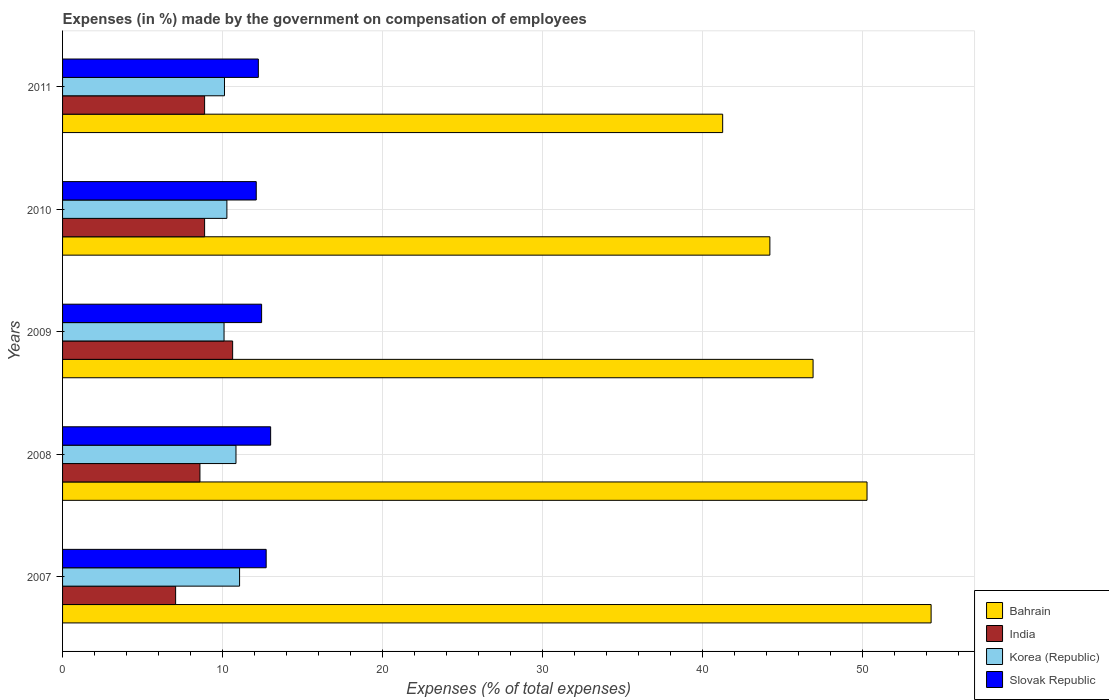How many groups of bars are there?
Provide a short and direct response. 5. Are the number of bars on each tick of the Y-axis equal?
Offer a terse response. Yes. How many bars are there on the 3rd tick from the top?
Your answer should be very brief. 4. How many bars are there on the 3rd tick from the bottom?
Provide a short and direct response. 4. What is the label of the 1st group of bars from the top?
Your answer should be very brief. 2011. In how many cases, is the number of bars for a given year not equal to the number of legend labels?
Your response must be concise. 0. What is the percentage of expenses made by the government on compensation of employees in Korea (Republic) in 2010?
Provide a short and direct response. 10.27. Across all years, what is the maximum percentage of expenses made by the government on compensation of employees in Bahrain?
Your answer should be compact. 54.31. Across all years, what is the minimum percentage of expenses made by the government on compensation of employees in India?
Provide a short and direct response. 7.07. What is the total percentage of expenses made by the government on compensation of employees in India in the graph?
Ensure brevity in your answer.  44.05. What is the difference between the percentage of expenses made by the government on compensation of employees in Korea (Republic) in 2007 and that in 2010?
Give a very brief answer. 0.79. What is the difference between the percentage of expenses made by the government on compensation of employees in India in 2008 and the percentage of expenses made by the government on compensation of employees in Bahrain in 2007?
Your answer should be very brief. -45.72. What is the average percentage of expenses made by the government on compensation of employees in Korea (Republic) per year?
Provide a short and direct response. 10.48. In the year 2008, what is the difference between the percentage of expenses made by the government on compensation of employees in Slovak Republic and percentage of expenses made by the government on compensation of employees in Korea (Republic)?
Offer a very short reply. 2.17. What is the ratio of the percentage of expenses made by the government on compensation of employees in India in 2007 to that in 2009?
Offer a very short reply. 0.66. What is the difference between the highest and the second highest percentage of expenses made by the government on compensation of employees in India?
Provide a short and direct response. 1.75. What is the difference between the highest and the lowest percentage of expenses made by the government on compensation of employees in Bahrain?
Ensure brevity in your answer.  13.03. Is the sum of the percentage of expenses made by the government on compensation of employees in Bahrain in 2008 and 2011 greater than the maximum percentage of expenses made by the government on compensation of employees in Slovak Republic across all years?
Your response must be concise. Yes. What does the 1st bar from the bottom in 2011 represents?
Give a very brief answer. Bahrain. Is it the case that in every year, the sum of the percentage of expenses made by the government on compensation of employees in Bahrain and percentage of expenses made by the government on compensation of employees in Korea (Republic) is greater than the percentage of expenses made by the government on compensation of employees in Slovak Republic?
Provide a succinct answer. Yes. Are all the bars in the graph horizontal?
Ensure brevity in your answer.  Yes. Are the values on the major ticks of X-axis written in scientific E-notation?
Provide a short and direct response. No. Does the graph contain any zero values?
Your answer should be very brief. No. How many legend labels are there?
Give a very brief answer. 4. How are the legend labels stacked?
Provide a short and direct response. Vertical. What is the title of the graph?
Provide a succinct answer. Expenses (in %) made by the government on compensation of employees. What is the label or title of the X-axis?
Your answer should be very brief. Expenses (% of total expenses). What is the Expenses (% of total expenses) of Bahrain in 2007?
Your answer should be very brief. 54.31. What is the Expenses (% of total expenses) in India in 2007?
Your answer should be compact. 7.07. What is the Expenses (% of total expenses) in Korea (Republic) in 2007?
Your answer should be very brief. 11.07. What is the Expenses (% of total expenses) in Slovak Republic in 2007?
Provide a short and direct response. 12.73. What is the Expenses (% of total expenses) in Bahrain in 2008?
Keep it short and to the point. 50.3. What is the Expenses (% of total expenses) of India in 2008?
Keep it short and to the point. 8.59. What is the Expenses (% of total expenses) in Korea (Republic) in 2008?
Your response must be concise. 10.84. What is the Expenses (% of total expenses) of Slovak Republic in 2008?
Keep it short and to the point. 13.01. What is the Expenses (% of total expenses) of Bahrain in 2009?
Ensure brevity in your answer.  46.93. What is the Expenses (% of total expenses) in India in 2009?
Provide a succinct answer. 10.63. What is the Expenses (% of total expenses) in Korea (Republic) in 2009?
Provide a short and direct response. 10.1. What is the Expenses (% of total expenses) of Slovak Republic in 2009?
Provide a short and direct response. 12.45. What is the Expenses (% of total expenses) of Bahrain in 2010?
Your response must be concise. 44.22. What is the Expenses (% of total expenses) in India in 2010?
Offer a very short reply. 8.88. What is the Expenses (% of total expenses) in Korea (Republic) in 2010?
Your response must be concise. 10.27. What is the Expenses (% of total expenses) of Slovak Republic in 2010?
Your answer should be compact. 12.11. What is the Expenses (% of total expenses) of Bahrain in 2011?
Offer a terse response. 41.27. What is the Expenses (% of total expenses) in India in 2011?
Give a very brief answer. 8.88. What is the Expenses (% of total expenses) in Korea (Republic) in 2011?
Your answer should be compact. 10.12. What is the Expenses (% of total expenses) of Slovak Republic in 2011?
Ensure brevity in your answer.  12.24. Across all years, what is the maximum Expenses (% of total expenses) in Bahrain?
Your answer should be compact. 54.31. Across all years, what is the maximum Expenses (% of total expenses) of India?
Provide a short and direct response. 10.63. Across all years, what is the maximum Expenses (% of total expenses) of Korea (Republic)?
Your response must be concise. 11.07. Across all years, what is the maximum Expenses (% of total expenses) in Slovak Republic?
Your response must be concise. 13.01. Across all years, what is the minimum Expenses (% of total expenses) of Bahrain?
Your answer should be very brief. 41.27. Across all years, what is the minimum Expenses (% of total expenses) of India?
Provide a short and direct response. 7.07. Across all years, what is the minimum Expenses (% of total expenses) in Korea (Republic)?
Provide a short and direct response. 10.1. Across all years, what is the minimum Expenses (% of total expenses) of Slovak Republic?
Ensure brevity in your answer.  12.11. What is the total Expenses (% of total expenses) in Bahrain in the graph?
Your answer should be compact. 237.03. What is the total Expenses (% of total expenses) in India in the graph?
Your answer should be very brief. 44.05. What is the total Expenses (% of total expenses) in Korea (Republic) in the graph?
Your response must be concise. 52.41. What is the total Expenses (% of total expenses) in Slovak Republic in the graph?
Provide a short and direct response. 62.54. What is the difference between the Expenses (% of total expenses) of Bahrain in 2007 and that in 2008?
Give a very brief answer. 4.01. What is the difference between the Expenses (% of total expenses) in India in 2007 and that in 2008?
Ensure brevity in your answer.  -1.52. What is the difference between the Expenses (% of total expenses) of Korea (Republic) in 2007 and that in 2008?
Your answer should be compact. 0.22. What is the difference between the Expenses (% of total expenses) in Slovak Republic in 2007 and that in 2008?
Make the answer very short. -0.28. What is the difference between the Expenses (% of total expenses) of Bahrain in 2007 and that in 2009?
Your answer should be very brief. 7.38. What is the difference between the Expenses (% of total expenses) of India in 2007 and that in 2009?
Offer a very short reply. -3.56. What is the difference between the Expenses (% of total expenses) of Korea (Republic) in 2007 and that in 2009?
Your response must be concise. 0.97. What is the difference between the Expenses (% of total expenses) in Slovak Republic in 2007 and that in 2009?
Offer a very short reply. 0.29. What is the difference between the Expenses (% of total expenses) of Bahrain in 2007 and that in 2010?
Provide a short and direct response. 10.08. What is the difference between the Expenses (% of total expenses) of India in 2007 and that in 2010?
Offer a very short reply. -1.81. What is the difference between the Expenses (% of total expenses) in Korea (Republic) in 2007 and that in 2010?
Offer a very short reply. 0.79. What is the difference between the Expenses (% of total expenses) of Slovak Republic in 2007 and that in 2010?
Give a very brief answer. 0.62. What is the difference between the Expenses (% of total expenses) of Bahrain in 2007 and that in 2011?
Offer a very short reply. 13.03. What is the difference between the Expenses (% of total expenses) in India in 2007 and that in 2011?
Make the answer very short. -1.81. What is the difference between the Expenses (% of total expenses) in Korea (Republic) in 2007 and that in 2011?
Keep it short and to the point. 0.94. What is the difference between the Expenses (% of total expenses) of Slovak Republic in 2007 and that in 2011?
Your answer should be compact. 0.49. What is the difference between the Expenses (% of total expenses) of Bahrain in 2008 and that in 2009?
Ensure brevity in your answer.  3.37. What is the difference between the Expenses (% of total expenses) in India in 2008 and that in 2009?
Make the answer very short. -2.04. What is the difference between the Expenses (% of total expenses) in Korea (Republic) in 2008 and that in 2009?
Make the answer very short. 0.75. What is the difference between the Expenses (% of total expenses) of Slovak Republic in 2008 and that in 2009?
Make the answer very short. 0.56. What is the difference between the Expenses (% of total expenses) in Bahrain in 2008 and that in 2010?
Your response must be concise. 6.08. What is the difference between the Expenses (% of total expenses) of India in 2008 and that in 2010?
Provide a short and direct response. -0.29. What is the difference between the Expenses (% of total expenses) in Korea (Republic) in 2008 and that in 2010?
Offer a very short reply. 0.57. What is the difference between the Expenses (% of total expenses) of Slovak Republic in 2008 and that in 2010?
Offer a terse response. 0.9. What is the difference between the Expenses (% of total expenses) of Bahrain in 2008 and that in 2011?
Provide a short and direct response. 9.03. What is the difference between the Expenses (% of total expenses) in India in 2008 and that in 2011?
Keep it short and to the point. -0.29. What is the difference between the Expenses (% of total expenses) in Korea (Republic) in 2008 and that in 2011?
Keep it short and to the point. 0.72. What is the difference between the Expenses (% of total expenses) in Slovak Republic in 2008 and that in 2011?
Give a very brief answer. 0.77. What is the difference between the Expenses (% of total expenses) in Bahrain in 2009 and that in 2010?
Give a very brief answer. 2.7. What is the difference between the Expenses (% of total expenses) in India in 2009 and that in 2010?
Ensure brevity in your answer.  1.75. What is the difference between the Expenses (% of total expenses) in Korea (Republic) in 2009 and that in 2010?
Offer a very short reply. -0.18. What is the difference between the Expenses (% of total expenses) in Slovak Republic in 2009 and that in 2010?
Offer a very short reply. 0.34. What is the difference between the Expenses (% of total expenses) in Bahrain in 2009 and that in 2011?
Give a very brief answer. 5.65. What is the difference between the Expenses (% of total expenses) in India in 2009 and that in 2011?
Your response must be concise. 1.75. What is the difference between the Expenses (% of total expenses) of Korea (Republic) in 2009 and that in 2011?
Ensure brevity in your answer.  -0.03. What is the difference between the Expenses (% of total expenses) in Slovak Republic in 2009 and that in 2011?
Your answer should be compact. 0.2. What is the difference between the Expenses (% of total expenses) in Bahrain in 2010 and that in 2011?
Offer a terse response. 2.95. What is the difference between the Expenses (% of total expenses) of Korea (Republic) in 2010 and that in 2011?
Provide a short and direct response. 0.15. What is the difference between the Expenses (% of total expenses) of Slovak Republic in 2010 and that in 2011?
Your response must be concise. -0.13. What is the difference between the Expenses (% of total expenses) in Bahrain in 2007 and the Expenses (% of total expenses) in India in 2008?
Keep it short and to the point. 45.72. What is the difference between the Expenses (% of total expenses) of Bahrain in 2007 and the Expenses (% of total expenses) of Korea (Republic) in 2008?
Offer a terse response. 43.46. What is the difference between the Expenses (% of total expenses) in Bahrain in 2007 and the Expenses (% of total expenses) in Slovak Republic in 2008?
Provide a short and direct response. 41.3. What is the difference between the Expenses (% of total expenses) of India in 2007 and the Expenses (% of total expenses) of Korea (Republic) in 2008?
Your response must be concise. -3.77. What is the difference between the Expenses (% of total expenses) in India in 2007 and the Expenses (% of total expenses) in Slovak Republic in 2008?
Provide a succinct answer. -5.94. What is the difference between the Expenses (% of total expenses) of Korea (Republic) in 2007 and the Expenses (% of total expenses) of Slovak Republic in 2008?
Offer a very short reply. -1.94. What is the difference between the Expenses (% of total expenses) in Bahrain in 2007 and the Expenses (% of total expenses) in India in 2009?
Your answer should be compact. 43.67. What is the difference between the Expenses (% of total expenses) of Bahrain in 2007 and the Expenses (% of total expenses) of Korea (Republic) in 2009?
Offer a very short reply. 44.21. What is the difference between the Expenses (% of total expenses) in Bahrain in 2007 and the Expenses (% of total expenses) in Slovak Republic in 2009?
Give a very brief answer. 41.86. What is the difference between the Expenses (% of total expenses) of India in 2007 and the Expenses (% of total expenses) of Korea (Republic) in 2009?
Give a very brief answer. -3.03. What is the difference between the Expenses (% of total expenses) in India in 2007 and the Expenses (% of total expenses) in Slovak Republic in 2009?
Give a very brief answer. -5.38. What is the difference between the Expenses (% of total expenses) in Korea (Republic) in 2007 and the Expenses (% of total expenses) in Slovak Republic in 2009?
Provide a succinct answer. -1.38. What is the difference between the Expenses (% of total expenses) of Bahrain in 2007 and the Expenses (% of total expenses) of India in 2010?
Keep it short and to the point. 45.42. What is the difference between the Expenses (% of total expenses) in Bahrain in 2007 and the Expenses (% of total expenses) in Korea (Republic) in 2010?
Give a very brief answer. 44.03. What is the difference between the Expenses (% of total expenses) of Bahrain in 2007 and the Expenses (% of total expenses) of Slovak Republic in 2010?
Ensure brevity in your answer.  42.2. What is the difference between the Expenses (% of total expenses) of India in 2007 and the Expenses (% of total expenses) of Korea (Republic) in 2010?
Keep it short and to the point. -3.2. What is the difference between the Expenses (% of total expenses) of India in 2007 and the Expenses (% of total expenses) of Slovak Republic in 2010?
Make the answer very short. -5.04. What is the difference between the Expenses (% of total expenses) in Korea (Republic) in 2007 and the Expenses (% of total expenses) in Slovak Republic in 2010?
Your answer should be very brief. -1.04. What is the difference between the Expenses (% of total expenses) in Bahrain in 2007 and the Expenses (% of total expenses) in India in 2011?
Keep it short and to the point. 45.42. What is the difference between the Expenses (% of total expenses) of Bahrain in 2007 and the Expenses (% of total expenses) of Korea (Republic) in 2011?
Give a very brief answer. 44.18. What is the difference between the Expenses (% of total expenses) in Bahrain in 2007 and the Expenses (% of total expenses) in Slovak Republic in 2011?
Give a very brief answer. 42.06. What is the difference between the Expenses (% of total expenses) in India in 2007 and the Expenses (% of total expenses) in Korea (Republic) in 2011?
Provide a short and direct response. -3.06. What is the difference between the Expenses (% of total expenses) of India in 2007 and the Expenses (% of total expenses) of Slovak Republic in 2011?
Ensure brevity in your answer.  -5.17. What is the difference between the Expenses (% of total expenses) in Korea (Republic) in 2007 and the Expenses (% of total expenses) in Slovak Republic in 2011?
Offer a terse response. -1.17. What is the difference between the Expenses (% of total expenses) of Bahrain in 2008 and the Expenses (% of total expenses) of India in 2009?
Your response must be concise. 39.67. What is the difference between the Expenses (% of total expenses) of Bahrain in 2008 and the Expenses (% of total expenses) of Korea (Republic) in 2009?
Keep it short and to the point. 40.2. What is the difference between the Expenses (% of total expenses) in Bahrain in 2008 and the Expenses (% of total expenses) in Slovak Republic in 2009?
Give a very brief answer. 37.85. What is the difference between the Expenses (% of total expenses) of India in 2008 and the Expenses (% of total expenses) of Korea (Republic) in 2009?
Your answer should be compact. -1.51. What is the difference between the Expenses (% of total expenses) in India in 2008 and the Expenses (% of total expenses) in Slovak Republic in 2009?
Offer a terse response. -3.86. What is the difference between the Expenses (% of total expenses) in Korea (Republic) in 2008 and the Expenses (% of total expenses) in Slovak Republic in 2009?
Ensure brevity in your answer.  -1.6. What is the difference between the Expenses (% of total expenses) of Bahrain in 2008 and the Expenses (% of total expenses) of India in 2010?
Keep it short and to the point. 41.42. What is the difference between the Expenses (% of total expenses) of Bahrain in 2008 and the Expenses (% of total expenses) of Korea (Republic) in 2010?
Make the answer very short. 40.03. What is the difference between the Expenses (% of total expenses) of Bahrain in 2008 and the Expenses (% of total expenses) of Slovak Republic in 2010?
Ensure brevity in your answer.  38.19. What is the difference between the Expenses (% of total expenses) in India in 2008 and the Expenses (% of total expenses) in Korea (Republic) in 2010?
Provide a short and direct response. -1.69. What is the difference between the Expenses (% of total expenses) of India in 2008 and the Expenses (% of total expenses) of Slovak Republic in 2010?
Give a very brief answer. -3.52. What is the difference between the Expenses (% of total expenses) of Korea (Republic) in 2008 and the Expenses (% of total expenses) of Slovak Republic in 2010?
Your response must be concise. -1.27. What is the difference between the Expenses (% of total expenses) of Bahrain in 2008 and the Expenses (% of total expenses) of India in 2011?
Offer a terse response. 41.42. What is the difference between the Expenses (% of total expenses) of Bahrain in 2008 and the Expenses (% of total expenses) of Korea (Republic) in 2011?
Ensure brevity in your answer.  40.17. What is the difference between the Expenses (% of total expenses) of Bahrain in 2008 and the Expenses (% of total expenses) of Slovak Republic in 2011?
Give a very brief answer. 38.06. What is the difference between the Expenses (% of total expenses) in India in 2008 and the Expenses (% of total expenses) in Korea (Republic) in 2011?
Your response must be concise. -1.54. What is the difference between the Expenses (% of total expenses) in India in 2008 and the Expenses (% of total expenses) in Slovak Republic in 2011?
Make the answer very short. -3.65. What is the difference between the Expenses (% of total expenses) of Korea (Republic) in 2008 and the Expenses (% of total expenses) of Slovak Republic in 2011?
Your answer should be compact. -1.4. What is the difference between the Expenses (% of total expenses) in Bahrain in 2009 and the Expenses (% of total expenses) in India in 2010?
Keep it short and to the point. 38.04. What is the difference between the Expenses (% of total expenses) of Bahrain in 2009 and the Expenses (% of total expenses) of Korea (Republic) in 2010?
Your response must be concise. 36.65. What is the difference between the Expenses (% of total expenses) in Bahrain in 2009 and the Expenses (% of total expenses) in Slovak Republic in 2010?
Provide a succinct answer. 34.82. What is the difference between the Expenses (% of total expenses) of India in 2009 and the Expenses (% of total expenses) of Korea (Republic) in 2010?
Give a very brief answer. 0.36. What is the difference between the Expenses (% of total expenses) in India in 2009 and the Expenses (% of total expenses) in Slovak Republic in 2010?
Keep it short and to the point. -1.48. What is the difference between the Expenses (% of total expenses) in Korea (Republic) in 2009 and the Expenses (% of total expenses) in Slovak Republic in 2010?
Provide a short and direct response. -2.01. What is the difference between the Expenses (% of total expenses) in Bahrain in 2009 and the Expenses (% of total expenses) in India in 2011?
Keep it short and to the point. 38.04. What is the difference between the Expenses (% of total expenses) in Bahrain in 2009 and the Expenses (% of total expenses) in Korea (Republic) in 2011?
Provide a short and direct response. 36.8. What is the difference between the Expenses (% of total expenses) in Bahrain in 2009 and the Expenses (% of total expenses) in Slovak Republic in 2011?
Your response must be concise. 34.68. What is the difference between the Expenses (% of total expenses) in India in 2009 and the Expenses (% of total expenses) in Korea (Republic) in 2011?
Give a very brief answer. 0.51. What is the difference between the Expenses (% of total expenses) of India in 2009 and the Expenses (% of total expenses) of Slovak Republic in 2011?
Provide a succinct answer. -1.61. What is the difference between the Expenses (% of total expenses) in Korea (Republic) in 2009 and the Expenses (% of total expenses) in Slovak Republic in 2011?
Provide a short and direct response. -2.14. What is the difference between the Expenses (% of total expenses) in Bahrain in 2010 and the Expenses (% of total expenses) in India in 2011?
Offer a terse response. 35.34. What is the difference between the Expenses (% of total expenses) in Bahrain in 2010 and the Expenses (% of total expenses) in Korea (Republic) in 2011?
Your answer should be very brief. 34.1. What is the difference between the Expenses (% of total expenses) in Bahrain in 2010 and the Expenses (% of total expenses) in Slovak Republic in 2011?
Make the answer very short. 31.98. What is the difference between the Expenses (% of total expenses) in India in 2010 and the Expenses (% of total expenses) in Korea (Republic) in 2011?
Keep it short and to the point. -1.24. What is the difference between the Expenses (% of total expenses) in India in 2010 and the Expenses (% of total expenses) in Slovak Republic in 2011?
Offer a very short reply. -3.36. What is the difference between the Expenses (% of total expenses) in Korea (Republic) in 2010 and the Expenses (% of total expenses) in Slovak Republic in 2011?
Your response must be concise. -1.97. What is the average Expenses (% of total expenses) in Bahrain per year?
Give a very brief answer. 47.41. What is the average Expenses (% of total expenses) of India per year?
Ensure brevity in your answer.  8.81. What is the average Expenses (% of total expenses) of Korea (Republic) per year?
Your answer should be very brief. 10.48. What is the average Expenses (% of total expenses) in Slovak Republic per year?
Keep it short and to the point. 12.51. In the year 2007, what is the difference between the Expenses (% of total expenses) of Bahrain and Expenses (% of total expenses) of India?
Ensure brevity in your answer.  47.24. In the year 2007, what is the difference between the Expenses (% of total expenses) in Bahrain and Expenses (% of total expenses) in Korea (Republic)?
Make the answer very short. 43.24. In the year 2007, what is the difference between the Expenses (% of total expenses) in Bahrain and Expenses (% of total expenses) in Slovak Republic?
Offer a terse response. 41.58. In the year 2007, what is the difference between the Expenses (% of total expenses) in India and Expenses (% of total expenses) in Korea (Republic)?
Give a very brief answer. -4. In the year 2007, what is the difference between the Expenses (% of total expenses) in India and Expenses (% of total expenses) in Slovak Republic?
Your answer should be very brief. -5.66. In the year 2007, what is the difference between the Expenses (% of total expenses) in Korea (Republic) and Expenses (% of total expenses) in Slovak Republic?
Offer a terse response. -1.66. In the year 2008, what is the difference between the Expenses (% of total expenses) of Bahrain and Expenses (% of total expenses) of India?
Provide a succinct answer. 41.71. In the year 2008, what is the difference between the Expenses (% of total expenses) of Bahrain and Expenses (% of total expenses) of Korea (Republic)?
Your response must be concise. 39.46. In the year 2008, what is the difference between the Expenses (% of total expenses) of Bahrain and Expenses (% of total expenses) of Slovak Republic?
Your answer should be very brief. 37.29. In the year 2008, what is the difference between the Expenses (% of total expenses) of India and Expenses (% of total expenses) of Korea (Republic)?
Keep it short and to the point. -2.25. In the year 2008, what is the difference between the Expenses (% of total expenses) of India and Expenses (% of total expenses) of Slovak Republic?
Provide a short and direct response. -4.42. In the year 2008, what is the difference between the Expenses (% of total expenses) in Korea (Republic) and Expenses (% of total expenses) in Slovak Republic?
Provide a short and direct response. -2.17. In the year 2009, what is the difference between the Expenses (% of total expenses) in Bahrain and Expenses (% of total expenses) in India?
Ensure brevity in your answer.  36.29. In the year 2009, what is the difference between the Expenses (% of total expenses) in Bahrain and Expenses (% of total expenses) in Korea (Republic)?
Give a very brief answer. 36.83. In the year 2009, what is the difference between the Expenses (% of total expenses) of Bahrain and Expenses (% of total expenses) of Slovak Republic?
Your answer should be compact. 34.48. In the year 2009, what is the difference between the Expenses (% of total expenses) of India and Expenses (% of total expenses) of Korea (Republic)?
Provide a succinct answer. 0.54. In the year 2009, what is the difference between the Expenses (% of total expenses) of India and Expenses (% of total expenses) of Slovak Republic?
Keep it short and to the point. -1.81. In the year 2009, what is the difference between the Expenses (% of total expenses) of Korea (Republic) and Expenses (% of total expenses) of Slovak Republic?
Offer a very short reply. -2.35. In the year 2010, what is the difference between the Expenses (% of total expenses) of Bahrain and Expenses (% of total expenses) of India?
Your response must be concise. 35.34. In the year 2010, what is the difference between the Expenses (% of total expenses) of Bahrain and Expenses (% of total expenses) of Korea (Republic)?
Keep it short and to the point. 33.95. In the year 2010, what is the difference between the Expenses (% of total expenses) in Bahrain and Expenses (% of total expenses) in Slovak Republic?
Your answer should be very brief. 32.11. In the year 2010, what is the difference between the Expenses (% of total expenses) in India and Expenses (% of total expenses) in Korea (Republic)?
Offer a terse response. -1.39. In the year 2010, what is the difference between the Expenses (% of total expenses) in India and Expenses (% of total expenses) in Slovak Republic?
Provide a short and direct response. -3.23. In the year 2010, what is the difference between the Expenses (% of total expenses) of Korea (Republic) and Expenses (% of total expenses) of Slovak Republic?
Your answer should be compact. -1.84. In the year 2011, what is the difference between the Expenses (% of total expenses) in Bahrain and Expenses (% of total expenses) in India?
Make the answer very short. 32.39. In the year 2011, what is the difference between the Expenses (% of total expenses) of Bahrain and Expenses (% of total expenses) of Korea (Republic)?
Your answer should be compact. 31.15. In the year 2011, what is the difference between the Expenses (% of total expenses) in Bahrain and Expenses (% of total expenses) in Slovak Republic?
Make the answer very short. 29.03. In the year 2011, what is the difference between the Expenses (% of total expenses) in India and Expenses (% of total expenses) in Korea (Republic)?
Ensure brevity in your answer.  -1.24. In the year 2011, what is the difference between the Expenses (% of total expenses) of India and Expenses (% of total expenses) of Slovak Republic?
Your response must be concise. -3.36. In the year 2011, what is the difference between the Expenses (% of total expenses) in Korea (Republic) and Expenses (% of total expenses) in Slovak Republic?
Make the answer very short. -2.12. What is the ratio of the Expenses (% of total expenses) of Bahrain in 2007 to that in 2008?
Ensure brevity in your answer.  1.08. What is the ratio of the Expenses (% of total expenses) of India in 2007 to that in 2008?
Your answer should be very brief. 0.82. What is the ratio of the Expenses (% of total expenses) of Korea (Republic) in 2007 to that in 2008?
Keep it short and to the point. 1.02. What is the ratio of the Expenses (% of total expenses) of Slovak Republic in 2007 to that in 2008?
Provide a succinct answer. 0.98. What is the ratio of the Expenses (% of total expenses) of Bahrain in 2007 to that in 2009?
Provide a short and direct response. 1.16. What is the ratio of the Expenses (% of total expenses) in India in 2007 to that in 2009?
Provide a short and direct response. 0.66. What is the ratio of the Expenses (% of total expenses) in Korea (Republic) in 2007 to that in 2009?
Ensure brevity in your answer.  1.1. What is the ratio of the Expenses (% of total expenses) in Slovak Republic in 2007 to that in 2009?
Keep it short and to the point. 1.02. What is the ratio of the Expenses (% of total expenses) of Bahrain in 2007 to that in 2010?
Your response must be concise. 1.23. What is the ratio of the Expenses (% of total expenses) in India in 2007 to that in 2010?
Provide a short and direct response. 0.8. What is the ratio of the Expenses (% of total expenses) of Korea (Republic) in 2007 to that in 2010?
Keep it short and to the point. 1.08. What is the ratio of the Expenses (% of total expenses) of Slovak Republic in 2007 to that in 2010?
Ensure brevity in your answer.  1.05. What is the ratio of the Expenses (% of total expenses) in Bahrain in 2007 to that in 2011?
Your answer should be very brief. 1.32. What is the ratio of the Expenses (% of total expenses) of India in 2007 to that in 2011?
Offer a very short reply. 0.8. What is the ratio of the Expenses (% of total expenses) of Korea (Republic) in 2007 to that in 2011?
Your answer should be compact. 1.09. What is the ratio of the Expenses (% of total expenses) in Slovak Republic in 2007 to that in 2011?
Offer a terse response. 1.04. What is the ratio of the Expenses (% of total expenses) in Bahrain in 2008 to that in 2009?
Your response must be concise. 1.07. What is the ratio of the Expenses (% of total expenses) of India in 2008 to that in 2009?
Ensure brevity in your answer.  0.81. What is the ratio of the Expenses (% of total expenses) of Korea (Republic) in 2008 to that in 2009?
Give a very brief answer. 1.07. What is the ratio of the Expenses (% of total expenses) in Slovak Republic in 2008 to that in 2009?
Your answer should be compact. 1.05. What is the ratio of the Expenses (% of total expenses) of Bahrain in 2008 to that in 2010?
Provide a succinct answer. 1.14. What is the ratio of the Expenses (% of total expenses) in India in 2008 to that in 2010?
Give a very brief answer. 0.97. What is the ratio of the Expenses (% of total expenses) of Korea (Republic) in 2008 to that in 2010?
Give a very brief answer. 1.06. What is the ratio of the Expenses (% of total expenses) of Slovak Republic in 2008 to that in 2010?
Your answer should be very brief. 1.07. What is the ratio of the Expenses (% of total expenses) in Bahrain in 2008 to that in 2011?
Ensure brevity in your answer.  1.22. What is the ratio of the Expenses (% of total expenses) of India in 2008 to that in 2011?
Provide a succinct answer. 0.97. What is the ratio of the Expenses (% of total expenses) of Korea (Republic) in 2008 to that in 2011?
Offer a terse response. 1.07. What is the ratio of the Expenses (% of total expenses) in Slovak Republic in 2008 to that in 2011?
Ensure brevity in your answer.  1.06. What is the ratio of the Expenses (% of total expenses) of Bahrain in 2009 to that in 2010?
Keep it short and to the point. 1.06. What is the ratio of the Expenses (% of total expenses) of India in 2009 to that in 2010?
Keep it short and to the point. 1.2. What is the ratio of the Expenses (% of total expenses) of Korea (Republic) in 2009 to that in 2010?
Your answer should be compact. 0.98. What is the ratio of the Expenses (% of total expenses) in Slovak Republic in 2009 to that in 2010?
Your response must be concise. 1.03. What is the ratio of the Expenses (% of total expenses) of Bahrain in 2009 to that in 2011?
Your answer should be very brief. 1.14. What is the ratio of the Expenses (% of total expenses) of India in 2009 to that in 2011?
Ensure brevity in your answer.  1.2. What is the ratio of the Expenses (% of total expenses) in Slovak Republic in 2009 to that in 2011?
Provide a short and direct response. 1.02. What is the ratio of the Expenses (% of total expenses) of Bahrain in 2010 to that in 2011?
Your response must be concise. 1.07. What is the ratio of the Expenses (% of total expenses) in Korea (Republic) in 2010 to that in 2011?
Give a very brief answer. 1.01. What is the ratio of the Expenses (% of total expenses) in Slovak Republic in 2010 to that in 2011?
Make the answer very short. 0.99. What is the difference between the highest and the second highest Expenses (% of total expenses) in Bahrain?
Make the answer very short. 4.01. What is the difference between the highest and the second highest Expenses (% of total expenses) in India?
Offer a terse response. 1.75. What is the difference between the highest and the second highest Expenses (% of total expenses) of Korea (Republic)?
Offer a very short reply. 0.22. What is the difference between the highest and the second highest Expenses (% of total expenses) in Slovak Republic?
Make the answer very short. 0.28. What is the difference between the highest and the lowest Expenses (% of total expenses) in Bahrain?
Your answer should be very brief. 13.03. What is the difference between the highest and the lowest Expenses (% of total expenses) in India?
Provide a succinct answer. 3.56. What is the difference between the highest and the lowest Expenses (% of total expenses) in Korea (Republic)?
Your response must be concise. 0.97. What is the difference between the highest and the lowest Expenses (% of total expenses) of Slovak Republic?
Offer a very short reply. 0.9. 